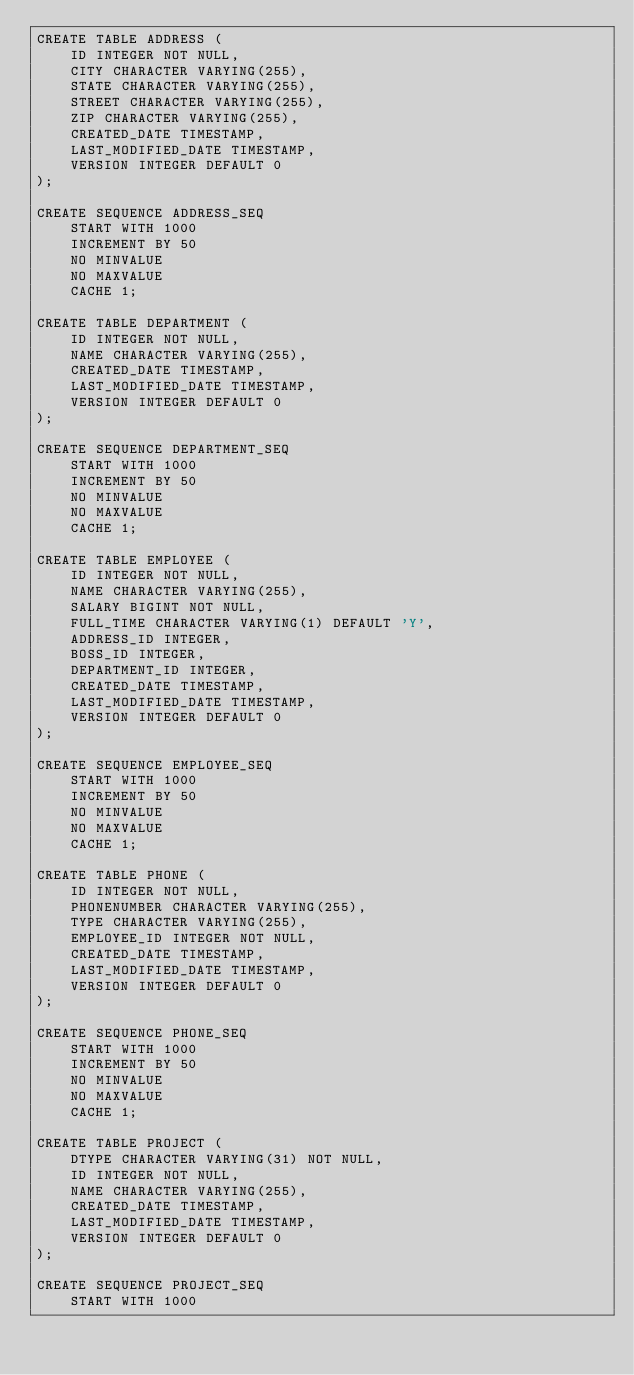Convert code to text. <code><loc_0><loc_0><loc_500><loc_500><_SQL_>CREATE TABLE ADDRESS (
    ID INTEGER NOT NULL,
    CITY CHARACTER VARYING(255),
    STATE CHARACTER VARYING(255),
    STREET CHARACTER VARYING(255),
    ZIP CHARACTER VARYING(255),
    CREATED_DATE TIMESTAMP,
    LAST_MODIFIED_DATE TIMESTAMP,
    VERSION INTEGER DEFAULT 0
);

CREATE SEQUENCE ADDRESS_SEQ
    START WITH 1000
    INCREMENT BY 50
    NO MINVALUE
    NO MAXVALUE
    CACHE 1;

CREATE TABLE DEPARTMENT (
    ID INTEGER NOT NULL,
    NAME CHARACTER VARYING(255),
    CREATED_DATE TIMESTAMP,
    LAST_MODIFIED_DATE TIMESTAMP,
    VERSION INTEGER DEFAULT 0
);

CREATE SEQUENCE DEPARTMENT_SEQ
    START WITH 1000
    INCREMENT BY 50
    NO MINVALUE
    NO MAXVALUE
    CACHE 1;

CREATE TABLE EMPLOYEE (
    ID INTEGER NOT NULL,
    NAME CHARACTER VARYING(255),
    SALARY BIGINT NOT NULL,
    FULL_TIME CHARACTER VARYING(1) DEFAULT 'Y',
    ADDRESS_ID INTEGER,
    BOSS_ID INTEGER,
    DEPARTMENT_ID INTEGER,
    CREATED_DATE TIMESTAMP,
    LAST_MODIFIED_DATE TIMESTAMP,
    VERSION INTEGER DEFAULT 0
);

CREATE SEQUENCE EMPLOYEE_SEQ
    START WITH 1000
    INCREMENT BY 50
    NO MINVALUE
    NO MAXVALUE
    CACHE 1;

CREATE TABLE PHONE (
    ID INTEGER NOT NULL,
    PHONENUMBER CHARACTER VARYING(255),
    TYPE CHARACTER VARYING(255),
    EMPLOYEE_ID INTEGER NOT NULL,
    CREATED_DATE TIMESTAMP,
    LAST_MODIFIED_DATE TIMESTAMP,
    VERSION INTEGER DEFAULT 0
);

CREATE SEQUENCE PHONE_SEQ
    START WITH 1000
    INCREMENT BY 50
    NO MINVALUE
    NO MAXVALUE
    CACHE 1;

CREATE TABLE PROJECT (
    DTYPE CHARACTER VARYING(31) NOT NULL,
    ID INTEGER NOT NULL,
    NAME CHARACTER VARYING(255),
    CREATED_DATE TIMESTAMP,
    LAST_MODIFIED_DATE TIMESTAMP,
    VERSION INTEGER DEFAULT 0
);

CREATE SEQUENCE PROJECT_SEQ
    START WITH 1000</code> 